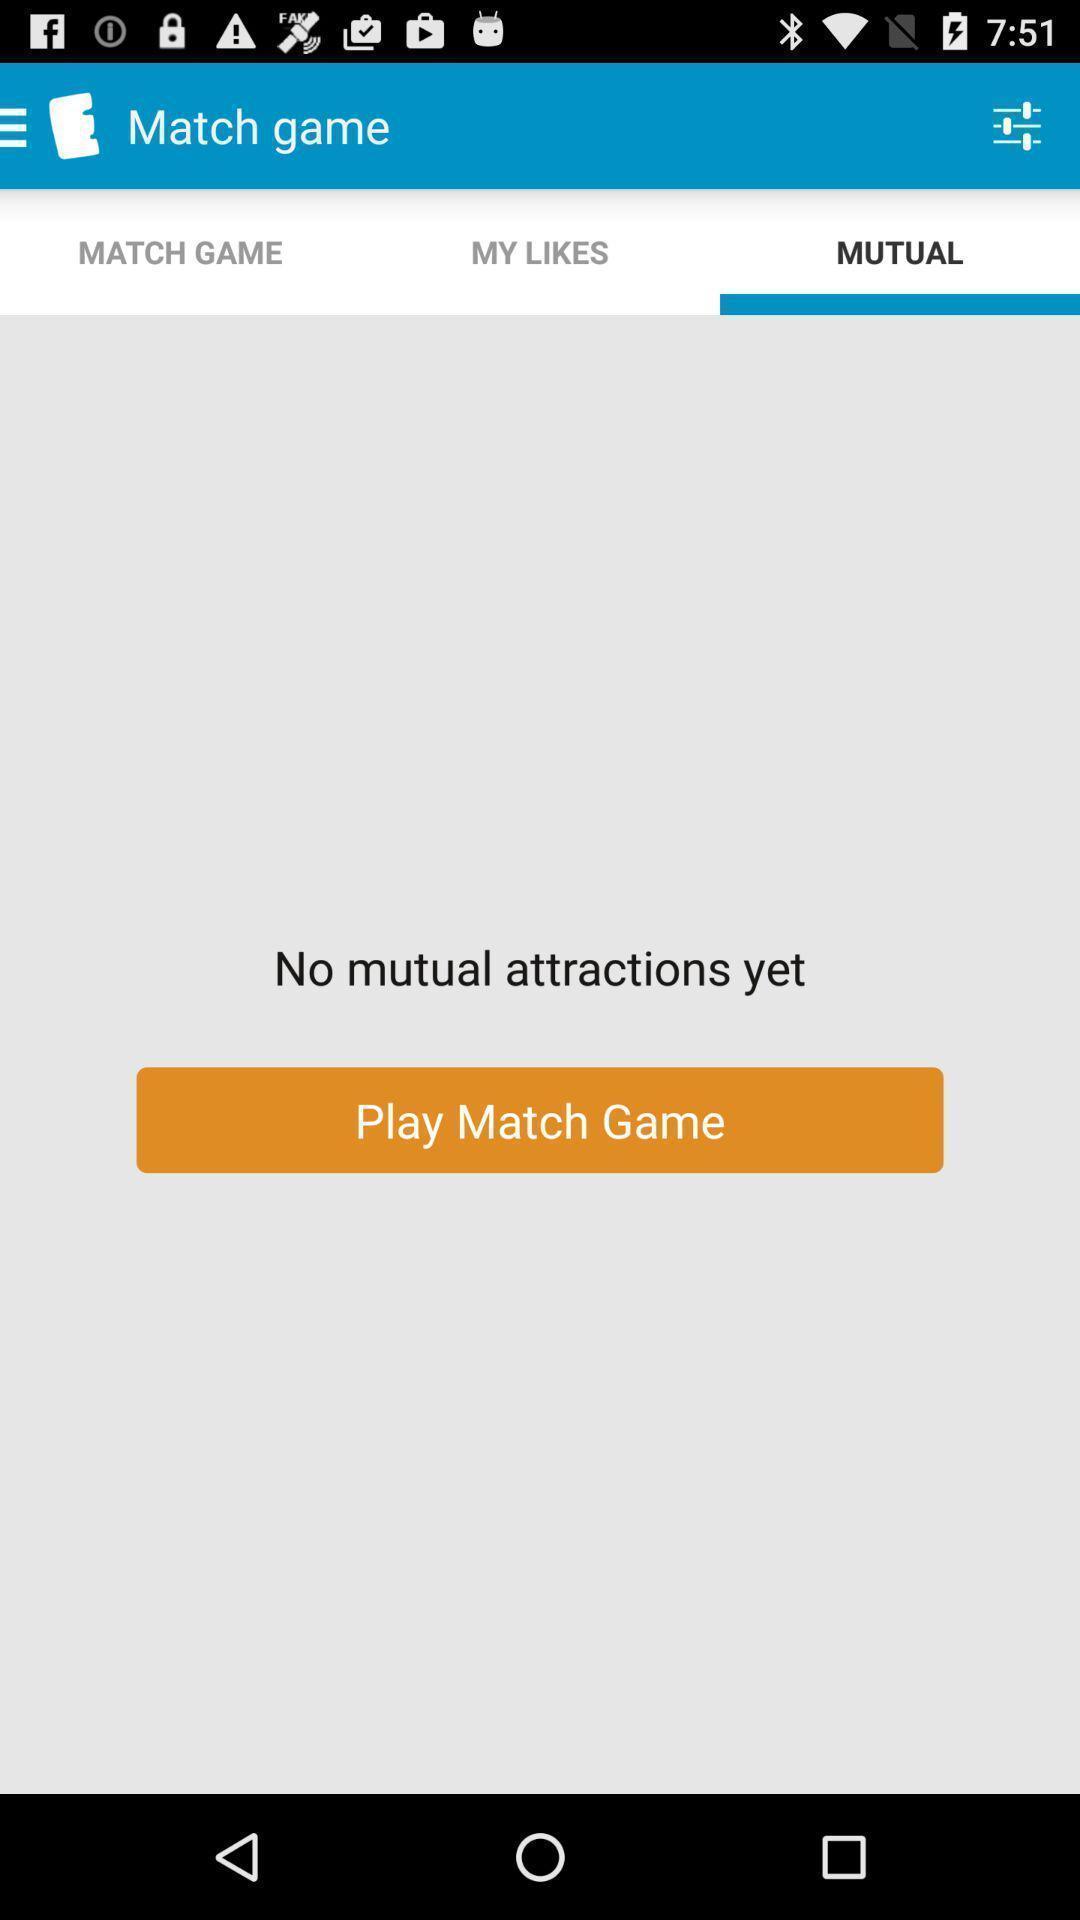What can you discern from this picture? Screen displaying the mutual play option in gaming app. 